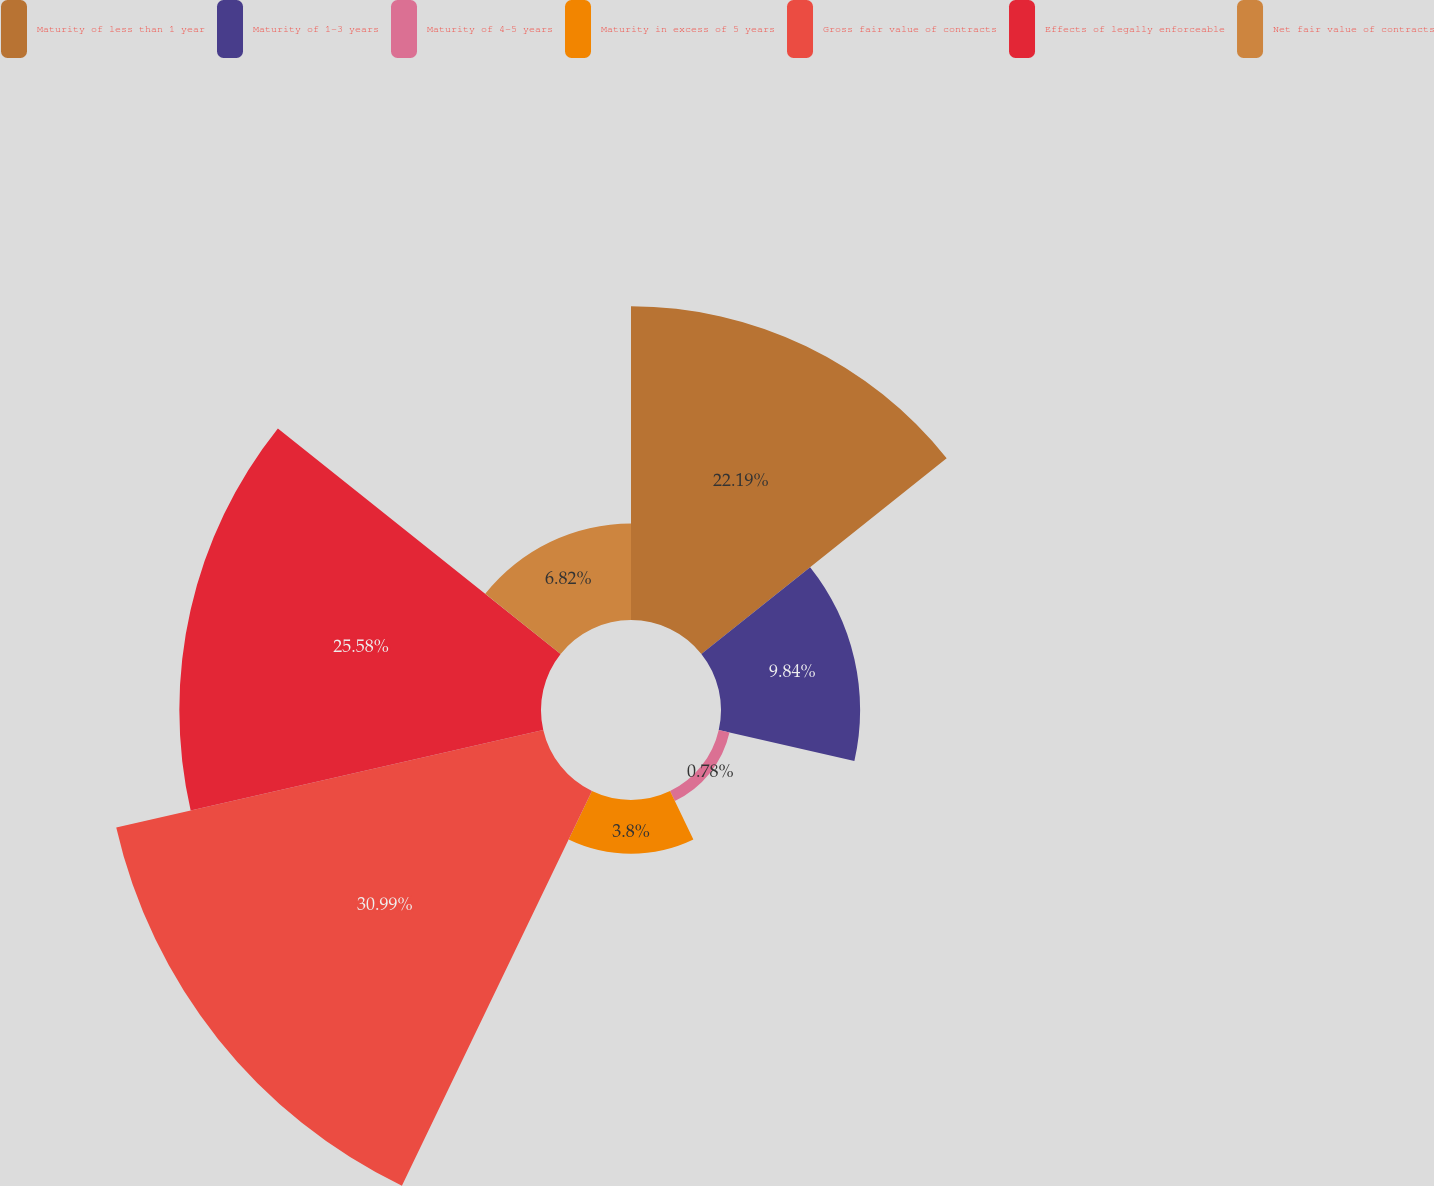Convert chart to OTSL. <chart><loc_0><loc_0><loc_500><loc_500><pie_chart><fcel>Maturity of less than 1 year<fcel>Maturity of 1-3 years<fcel>Maturity of 4-5 years<fcel>Maturity in excess of 5 years<fcel>Gross fair value of contracts<fcel>Effects of legally enforceable<fcel>Net fair value of contracts<nl><fcel>22.19%<fcel>9.84%<fcel>0.78%<fcel>3.8%<fcel>30.98%<fcel>25.58%<fcel>6.82%<nl></chart> 